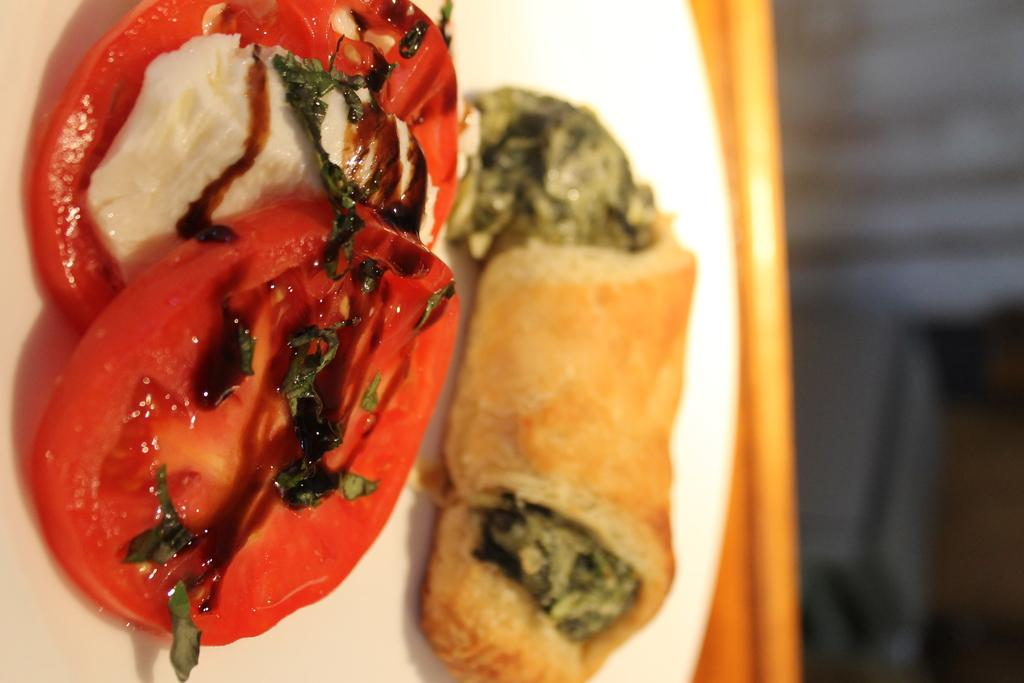What is on the plate that is visible in the image? There are two slices of a tomato on the plate. Are there any other items on the plate besides the tomato slices? Yes, there are leaves and other foodstuffs visible on the plate. What color is the plate in the image? The plate is white. How is the image quality? The image is slightly blurry. Where is the throne located in the image? There is no throne present in the image. What color is the sky in the image? The provided facts do not mention the sky, so we cannot determine its color from the image. 